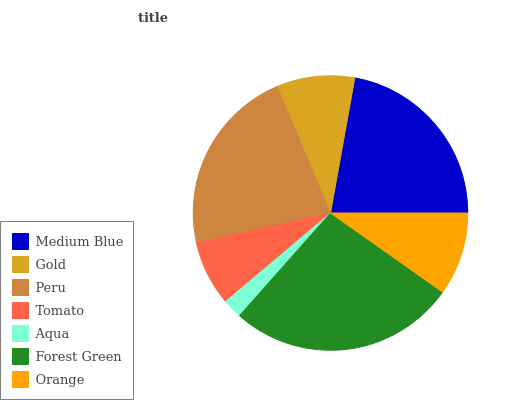Is Aqua the minimum?
Answer yes or no. Yes. Is Forest Green the maximum?
Answer yes or no. Yes. Is Gold the minimum?
Answer yes or no. No. Is Gold the maximum?
Answer yes or no. No. Is Medium Blue greater than Gold?
Answer yes or no. Yes. Is Gold less than Medium Blue?
Answer yes or no. Yes. Is Gold greater than Medium Blue?
Answer yes or no. No. Is Medium Blue less than Gold?
Answer yes or no. No. Is Orange the high median?
Answer yes or no. Yes. Is Orange the low median?
Answer yes or no. Yes. Is Gold the high median?
Answer yes or no. No. Is Gold the low median?
Answer yes or no. No. 